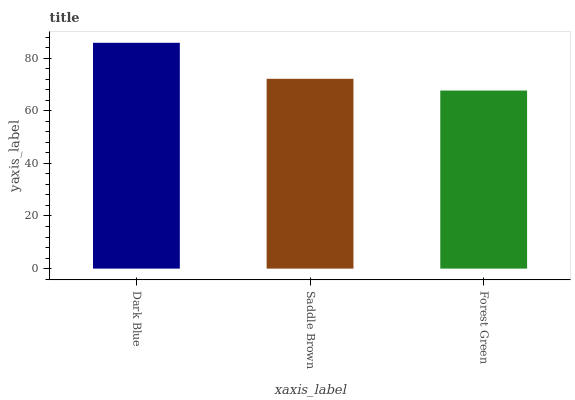Is Forest Green the minimum?
Answer yes or no. Yes. Is Dark Blue the maximum?
Answer yes or no. Yes. Is Saddle Brown the minimum?
Answer yes or no. No. Is Saddle Brown the maximum?
Answer yes or no. No. Is Dark Blue greater than Saddle Brown?
Answer yes or no. Yes. Is Saddle Brown less than Dark Blue?
Answer yes or no. Yes. Is Saddle Brown greater than Dark Blue?
Answer yes or no. No. Is Dark Blue less than Saddle Brown?
Answer yes or no. No. Is Saddle Brown the high median?
Answer yes or no. Yes. Is Saddle Brown the low median?
Answer yes or no. Yes. Is Dark Blue the high median?
Answer yes or no. No. Is Forest Green the low median?
Answer yes or no. No. 